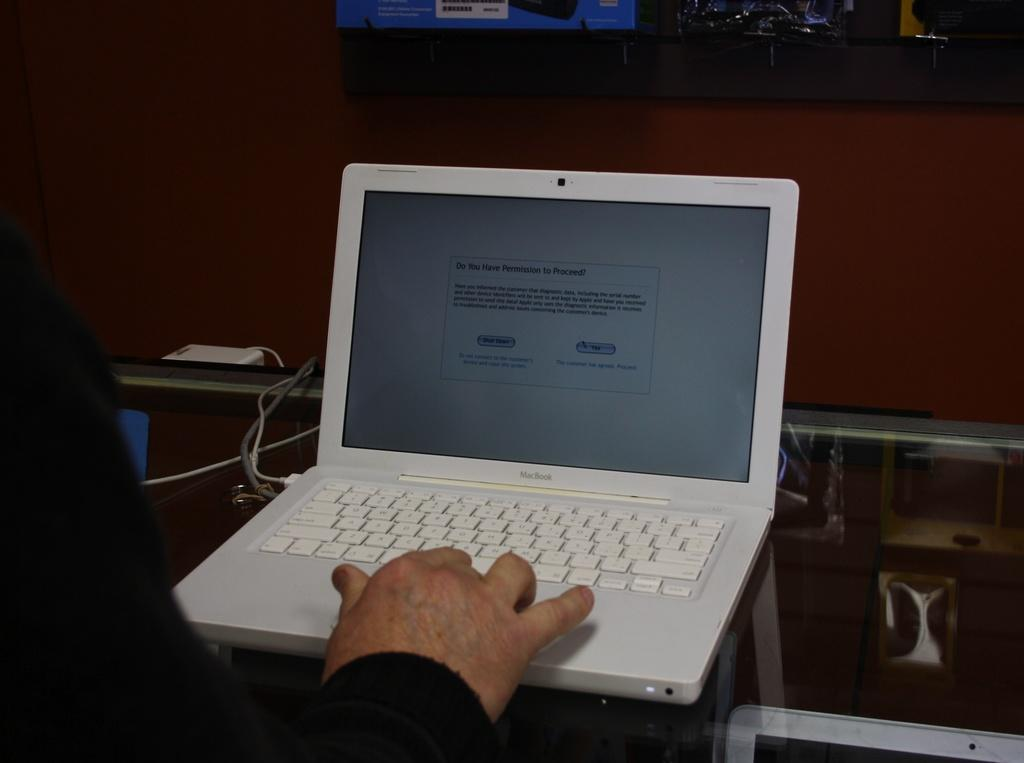<image>
Write a terse but informative summary of the picture. A person navigates a laptop with a screen asking if they have permission to proceed. 